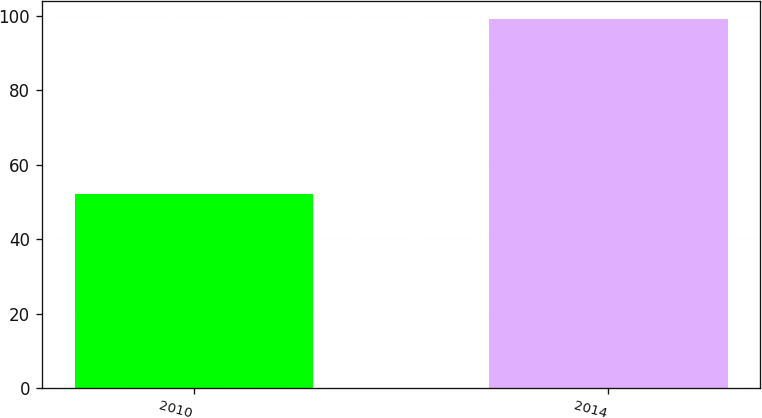Convert chart. <chart><loc_0><loc_0><loc_500><loc_500><bar_chart><fcel>2010<fcel>2014<nl><fcel>52<fcel>99<nl></chart> 